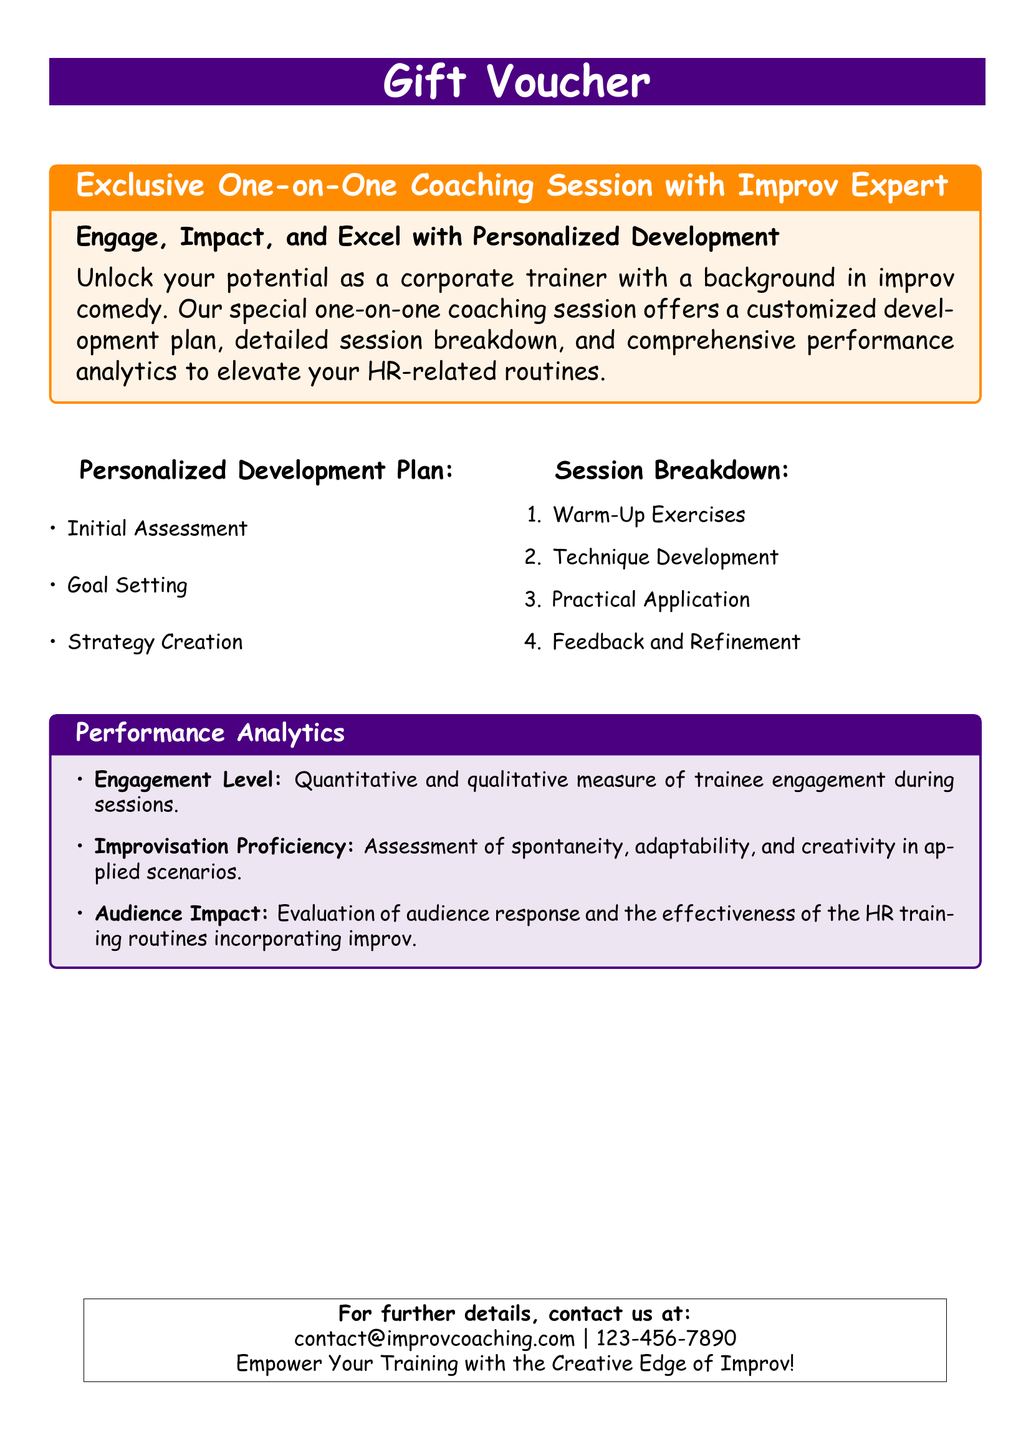What is the main purpose of the coaching session? The main purpose is to engage, impact, and excel with personalized development.
Answer: Engage, Impact, and Excel with Personalized Development What is the font used in the document? The document specifies the main font as Comic Sans MS.
Answer: Comic Sans MS What kind of assessment is part of the Personalized Development Plan? The document outlines that the initial assessment is part of the plan.
Answer: Initial Assessment How many items are listed in the Session Breakdown? There are four items listed in the Session Breakdown.
Answer: Four What is evaluated under Performance Analytics regarding trainee engagement? The engagement level is quantitatively and qualitatively measured during sessions.
Answer: Engagement Level What type of coaching does the voucher offer? The voucher offers an Exclusive One-on-One Coaching Session.
Answer: Exclusive One-on-One Coaching Session Who can be contacted for further details? The contact email provided in the document is contact@improvcoaching.com.
Answer: contact@improvcoaching.com What is the first step in the Personalized Development Plan? The first step is the Initial Assessment.
Answer: Initial Assessment What are Warm-Up Exercises categorized under? Warm-Up Exercises are categorized under Session Breakdown.
Answer: Session Breakdown 